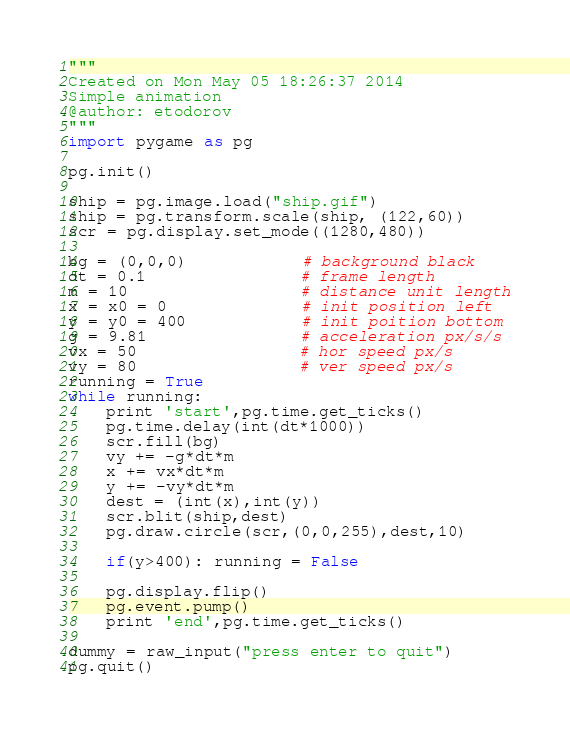<code> <loc_0><loc_0><loc_500><loc_500><_Python_>"""
Created on Mon May 05 18:26:37 2014
Simple animation
@author: etodorov
"""
import pygame as pg

pg.init()

ship = pg.image.load("ship.gif")
ship = pg.transform.scale(ship, (122,60))
scr = pg.display.set_mode((1280,480))

bg = (0,0,0)            # background black
dt = 0.1                # frame length
m = 10                  # distance unit length
x = x0 = 0              # init position left
y = y0 = 400            # init poition bottom 
g = 9.81                # acceleration px/s/s
vx = 50                 # hor speed px/s
vy = 80                 # ver speed px/s
running = True
while running:
    print 'start',pg.time.get_ticks()
    pg.time.delay(int(dt*1000))
    scr.fill(bg)
    vy += -g*dt*m
    x += vx*dt*m
    y += -vy*dt*m
    dest = (int(x),int(y))
    scr.blit(ship,dest)
    pg.draw.circle(scr,(0,0,255),dest,10)    
    
    if(y>400): running = False            
    
    pg.display.flip()
    pg.event.pump()
    print 'end',pg.time.get_ticks()

dummy = raw_input("press enter to quit")
pg.quit()</code> 